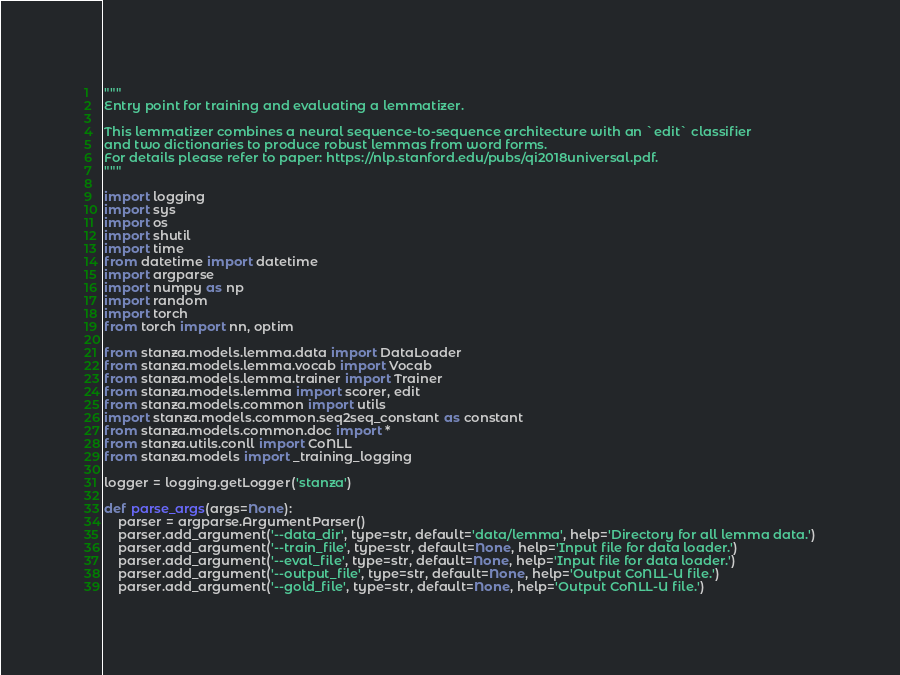<code> <loc_0><loc_0><loc_500><loc_500><_Python_>"""
Entry point for training and evaluating a lemmatizer.

This lemmatizer combines a neural sequence-to-sequence architecture with an `edit` classifier 
and two dictionaries to produce robust lemmas from word forms.
For details please refer to paper: https://nlp.stanford.edu/pubs/qi2018universal.pdf.
"""

import logging
import sys
import os
import shutil
import time
from datetime import datetime
import argparse
import numpy as np
import random
import torch
from torch import nn, optim

from stanza.models.lemma.data import DataLoader
from stanza.models.lemma.vocab import Vocab
from stanza.models.lemma.trainer import Trainer
from stanza.models.lemma import scorer, edit
from stanza.models.common import utils
import stanza.models.common.seq2seq_constant as constant
from stanza.models.common.doc import *
from stanza.utils.conll import CoNLL
from stanza.models import _training_logging

logger = logging.getLogger('stanza')

def parse_args(args=None):
    parser = argparse.ArgumentParser()
    parser.add_argument('--data_dir', type=str, default='data/lemma', help='Directory for all lemma data.')
    parser.add_argument('--train_file', type=str, default=None, help='Input file for data loader.')
    parser.add_argument('--eval_file', type=str, default=None, help='Input file for data loader.')
    parser.add_argument('--output_file', type=str, default=None, help='Output CoNLL-U file.')
    parser.add_argument('--gold_file', type=str, default=None, help='Output CoNLL-U file.')
</code> 